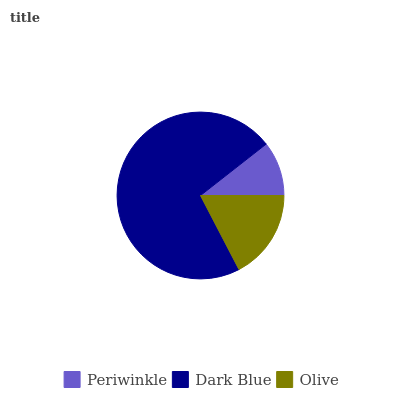Is Periwinkle the minimum?
Answer yes or no. Yes. Is Dark Blue the maximum?
Answer yes or no. Yes. Is Olive the minimum?
Answer yes or no. No. Is Olive the maximum?
Answer yes or no. No. Is Dark Blue greater than Olive?
Answer yes or no. Yes. Is Olive less than Dark Blue?
Answer yes or no. Yes. Is Olive greater than Dark Blue?
Answer yes or no. No. Is Dark Blue less than Olive?
Answer yes or no. No. Is Olive the high median?
Answer yes or no. Yes. Is Olive the low median?
Answer yes or no. Yes. Is Periwinkle the high median?
Answer yes or no. No. Is Dark Blue the low median?
Answer yes or no. No. 